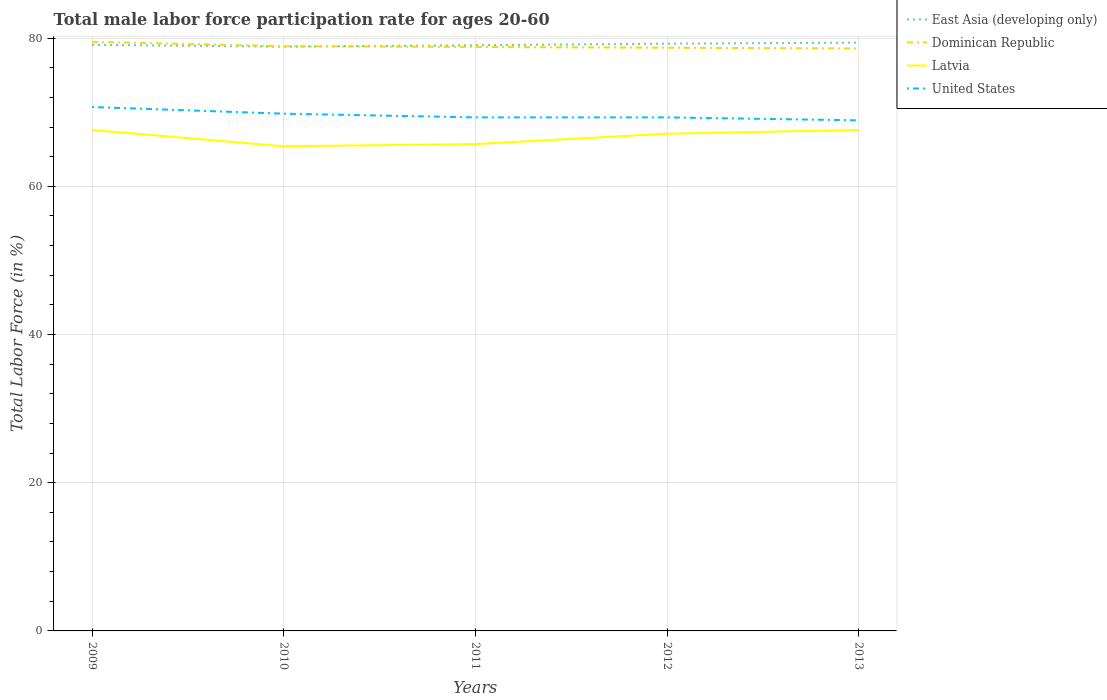How many different coloured lines are there?
Ensure brevity in your answer.  4. Is the number of lines equal to the number of legend labels?
Provide a short and direct response. Yes. Across all years, what is the maximum male labor force participation rate in United States?
Give a very brief answer. 68.9. In which year was the male labor force participation rate in East Asia (developing only) maximum?
Your response must be concise. 2010. What is the total male labor force participation rate in Dominican Republic in the graph?
Your answer should be compact. 0.6. What is the difference between the highest and the second highest male labor force participation rate in United States?
Your response must be concise. 1.8. What is the difference between the highest and the lowest male labor force participation rate in Dominican Republic?
Give a very brief answer. 2. How many years are there in the graph?
Your response must be concise. 5. What is the difference between two consecutive major ticks on the Y-axis?
Your response must be concise. 20. Are the values on the major ticks of Y-axis written in scientific E-notation?
Keep it short and to the point. No. Where does the legend appear in the graph?
Offer a terse response. Top right. How are the legend labels stacked?
Offer a very short reply. Vertical. What is the title of the graph?
Give a very brief answer. Total male labor force participation rate for ages 20-60. What is the label or title of the Y-axis?
Offer a terse response. Total Labor Force (in %). What is the Total Labor Force (in %) in East Asia (developing only) in 2009?
Your answer should be compact. 79.09. What is the Total Labor Force (in %) of Dominican Republic in 2009?
Give a very brief answer. 79.5. What is the Total Labor Force (in %) in Latvia in 2009?
Offer a terse response. 67.6. What is the Total Labor Force (in %) in United States in 2009?
Offer a terse response. 70.7. What is the Total Labor Force (in %) in East Asia (developing only) in 2010?
Give a very brief answer. 78.84. What is the Total Labor Force (in %) in Dominican Republic in 2010?
Your answer should be very brief. 78.9. What is the Total Labor Force (in %) in Latvia in 2010?
Your answer should be very brief. 65.4. What is the Total Labor Force (in %) in United States in 2010?
Keep it short and to the point. 69.8. What is the Total Labor Force (in %) of East Asia (developing only) in 2011?
Keep it short and to the point. 79.03. What is the Total Labor Force (in %) in Dominican Republic in 2011?
Your response must be concise. 78.8. What is the Total Labor Force (in %) in Latvia in 2011?
Give a very brief answer. 65.7. What is the Total Labor Force (in %) of United States in 2011?
Provide a succinct answer. 69.3. What is the Total Labor Force (in %) of East Asia (developing only) in 2012?
Make the answer very short. 79.25. What is the Total Labor Force (in %) in Dominican Republic in 2012?
Your answer should be compact. 78.7. What is the Total Labor Force (in %) of Latvia in 2012?
Provide a succinct answer. 67.1. What is the Total Labor Force (in %) of United States in 2012?
Give a very brief answer. 69.3. What is the Total Labor Force (in %) in East Asia (developing only) in 2013?
Your answer should be compact. 79.39. What is the Total Labor Force (in %) in Dominican Republic in 2013?
Offer a terse response. 78.6. What is the Total Labor Force (in %) of Latvia in 2013?
Give a very brief answer. 67.6. What is the Total Labor Force (in %) of United States in 2013?
Provide a short and direct response. 68.9. Across all years, what is the maximum Total Labor Force (in %) of East Asia (developing only)?
Offer a very short reply. 79.39. Across all years, what is the maximum Total Labor Force (in %) of Dominican Republic?
Ensure brevity in your answer.  79.5. Across all years, what is the maximum Total Labor Force (in %) of Latvia?
Ensure brevity in your answer.  67.6. Across all years, what is the maximum Total Labor Force (in %) of United States?
Ensure brevity in your answer.  70.7. Across all years, what is the minimum Total Labor Force (in %) of East Asia (developing only)?
Ensure brevity in your answer.  78.84. Across all years, what is the minimum Total Labor Force (in %) in Dominican Republic?
Your answer should be compact. 78.6. Across all years, what is the minimum Total Labor Force (in %) in Latvia?
Provide a succinct answer. 65.4. Across all years, what is the minimum Total Labor Force (in %) in United States?
Give a very brief answer. 68.9. What is the total Total Labor Force (in %) in East Asia (developing only) in the graph?
Ensure brevity in your answer.  395.6. What is the total Total Labor Force (in %) of Dominican Republic in the graph?
Provide a succinct answer. 394.5. What is the total Total Labor Force (in %) in Latvia in the graph?
Give a very brief answer. 333.4. What is the total Total Labor Force (in %) in United States in the graph?
Keep it short and to the point. 348. What is the difference between the Total Labor Force (in %) in East Asia (developing only) in 2009 and that in 2010?
Give a very brief answer. 0.25. What is the difference between the Total Labor Force (in %) in Latvia in 2009 and that in 2010?
Offer a terse response. 2.2. What is the difference between the Total Labor Force (in %) in United States in 2009 and that in 2010?
Give a very brief answer. 0.9. What is the difference between the Total Labor Force (in %) of East Asia (developing only) in 2009 and that in 2011?
Offer a very short reply. 0.06. What is the difference between the Total Labor Force (in %) in Latvia in 2009 and that in 2011?
Keep it short and to the point. 1.9. What is the difference between the Total Labor Force (in %) in United States in 2009 and that in 2011?
Make the answer very short. 1.4. What is the difference between the Total Labor Force (in %) in East Asia (developing only) in 2009 and that in 2012?
Ensure brevity in your answer.  -0.16. What is the difference between the Total Labor Force (in %) of Latvia in 2009 and that in 2012?
Provide a succinct answer. 0.5. What is the difference between the Total Labor Force (in %) in United States in 2009 and that in 2012?
Offer a very short reply. 1.4. What is the difference between the Total Labor Force (in %) of East Asia (developing only) in 2009 and that in 2013?
Ensure brevity in your answer.  -0.3. What is the difference between the Total Labor Force (in %) of Dominican Republic in 2009 and that in 2013?
Ensure brevity in your answer.  0.9. What is the difference between the Total Labor Force (in %) of Latvia in 2009 and that in 2013?
Offer a very short reply. 0. What is the difference between the Total Labor Force (in %) in East Asia (developing only) in 2010 and that in 2011?
Ensure brevity in your answer.  -0.19. What is the difference between the Total Labor Force (in %) in Dominican Republic in 2010 and that in 2011?
Keep it short and to the point. 0.1. What is the difference between the Total Labor Force (in %) of East Asia (developing only) in 2010 and that in 2012?
Your answer should be very brief. -0.4. What is the difference between the Total Labor Force (in %) of Dominican Republic in 2010 and that in 2012?
Your response must be concise. 0.2. What is the difference between the Total Labor Force (in %) in East Asia (developing only) in 2010 and that in 2013?
Provide a succinct answer. -0.55. What is the difference between the Total Labor Force (in %) of United States in 2010 and that in 2013?
Offer a very short reply. 0.9. What is the difference between the Total Labor Force (in %) in East Asia (developing only) in 2011 and that in 2012?
Ensure brevity in your answer.  -0.22. What is the difference between the Total Labor Force (in %) in Dominican Republic in 2011 and that in 2012?
Your answer should be compact. 0.1. What is the difference between the Total Labor Force (in %) of Latvia in 2011 and that in 2012?
Your answer should be very brief. -1.4. What is the difference between the Total Labor Force (in %) of East Asia (developing only) in 2011 and that in 2013?
Provide a succinct answer. -0.36. What is the difference between the Total Labor Force (in %) of Dominican Republic in 2011 and that in 2013?
Offer a terse response. 0.2. What is the difference between the Total Labor Force (in %) of Latvia in 2011 and that in 2013?
Provide a short and direct response. -1.9. What is the difference between the Total Labor Force (in %) of United States in 2011 and that in 2013?
Your answer should be compact. 0.4. What is the difference between the Total Labor Force (in %) of East Asia (developing only) in 2012 and that in 2013?
Offer a very short reply. -0.14. What is the difference between the Total Labor Force (in %) of Dominican Republic in 2012 and that in 2013?
Your answer should be very brief. 0.1. What is the difference between the Total Labor Force (in %) of Latvia in 2012 and that in 2013?
Offer a very short reply. -0.5. What is the difference between the Total Labor Force (in %) of United States in 2012 and that in 2013?
Offer a terse response. 0.4. What is the difference between the Total Labor Force (in %) in East Asia (developing only) in 2009 and the Total Labor Force (in %) in Dominican Republic in 2010?
Give a very brief answer. 0.19. What is the difference between the Total Labor Force (in %) of East Asia (developing only) in 2009 and the Total Labor Force (in %) of Latvia in 2010?
Offer a terse response. 13.69. What is the difference between the Total Labor Force (in %) in East Asia (developing only) in 2009 and the Total Labor Force (in %) in United States in 2010?
Your answer should be compact. 9.29. What is the difference between the Total Labor Force (in %) of Latvia in 2009 and the Total Labor Force (in %) of United States in 2010?
Your response must be concise. -2.2. What is the difference between the Total Labor Force (in %) in East Asia (developing only) in 2009 and the Total Labor Force (in %) in Dominican Republic in 2011?
Provide a short and direct response. 0.29. What is the difference between the Total Labor Force (in %) of East Asia (developing only) in 2009 and the Total Labor Force (in %) of Latvia in 2011?
Your response must be concise. 13.39. What is the difference between the Total Labor Force (in %) in East Asia (developing only) in 2009 and the Total Labor Force (in %) in United States in 2011?
Ensure brevity in your answer.  9.79. What is the difference between the Total Labor Force (in %) in Latvia in 2009 and the Total Labor Force (in %) in United States in 2011?
Keep it short and to the point. -1.7. What is the difference between the Total Labor Force (in %) in East Asia (developing only) in 2009 and the Total Labor Force (in %) in Dominican Republic in 2012?
Provide a succinct answer. 0.39. What is the difference between the Total Labor Force (in %) of East Asia (developing only) in 2009 and the Total Labor Force (in %) of Latvia in 2012?
Your answer should be compact. 11.99. What is the difference between the Total Labor Force (in %) in East Asia (developing only) in 2009 and the Total Labor Force (in %) in United States in 2012?
Give a very brief answer. 9.79. What is the difference between the Total Labor Force (in %) of Dominican Republic in 2009 and the Total Labor Force (in %) of United States in 2012?
Offer a very short reply. 10.2. What is the difference between the Total Labor Force (in %) of Latvia in 2009 and the Total Labor Force (in %) of United States in 2012?
Provide a succinct answer. -1.7. What is the difference between the Total Labor Force (in %) in East Asia (developing only) in 2009 and the Total Labor Force (in %) in Dominican Republic in 2013?
Make the answer very short. 0.49. What is the difference between the Total Labor Force (in %) in East Asia (developing only) in 2009 and the Total Labor Force (in %) in Latvia in 2013?
Offer a terse response. 11.49. What is the difference between the Total Labor Force (in %) in East Asia (developing only) in 2009 and the Total Labor Force (in %) in United States in 2013?
Your response must be concise. 10.19. What is the difference between the Total Labor Force (in %) in Dominican Republic in 2009 and the Total Labor Force (in %) in Latvia in 2013?
Give a very brief answer. 11.9. What is the difference between the Total Labor Force (in %) of Latvia in 2009 and the Total Labor Force (in %) of United States in 2013?
Your answer should be very brief. -1.3. What is the difference between the Total Labor Force (in %) in East Asia (developing only) in 2010 and the Total Labor Force (in %) in Dominican Republic in 2011?
Offer a very short reply. 0.04. What is the difference between the Total Labor Force (in %) of East Asia (developing only) in 2010 and the Total Labor Force (in %) of Latvia in 2011?
Keep it short and to the point. 13.14. What is the difference between the Total Labor Force (in %) of East Asia (developing only) in 2010 and the Total Labor Force (in %) of United States in 2011?
Offer a very short reply. 9.54. What is the difference between the Total Labor Force (in %) of Dominican Republic in 2010 and the Total Labor Force (in %) of Latvia in 2011?
Offer a terse response. 13.2. What is the difference between the Total Labor Force (in %) of Latvia in 2010 and the Total Labor Force (in %) of United States in 2011?
Your answer should be very brief. -3.9. What is the difference between the Total Labor Force (in %) in East Asia (developing only) in 2010 and the Total Labor Force (in %) in Dominican Republic in 2012?
Give a very brief answer. 0.14. What is the difference between the Total Labor Force (in %) in East Asia (developing only) in 2010 and the Total Labor Force (in %) in Latvia in 2012?
Your answer should be compact. 11.74. What is the difference between the Total Labor Force (in %) in East Asia (developing only) in 2010 and the Total Labor Force (in %) in United States in 2012?
Offer a very short reply. 9.54. What is the difference between the Total Labor Force (in %) in Dominican Republic in 2010 and the Total Labor Force (in %) in Latvia in 2012?
Offer a terse response. 11.8. What is the difference between the Total Labor Force (in %) of East Asia (developing only) in 2010 and the Total Labor Force (in %) of Dominican Republic in 2013?
Provide a succinct answer. 0.24. What is the difference between the Total Labor Force (in %) of East Asia (developing only) in 2010 and the Total Labor Force (in %) of Latvia in 2013?
Offer a terse response. 11.24. What is the difference between the Total Labor Force (in %) of East Asia (developing only) in 2010 and the Total Labor Force (in %) of United States in 2013?
Your response must be concise. 9.94. What is the difference between the Total Labor Force (in %) in East Asia (developing only) in 2011 and the Total Labor Force (in %) in Dominican Republic in 2012?
Ensure brevity in your answer.  0.33. What is the difference between the Total Labor Force (in %) in East Asia (developing only) in 2011 and the Total Labor Force (in %) in Latvia in 2012?
Your answer should be compact. 11.93. What is the difference between the Total Labor Force (in %) of East Asia (developing only) in 2011 and the Total Labor Force (in %) of United States in 2012?
Keep it short and to the point. 9.73. What is the difference between the Total Labor Force (in %) in Dominican Republic in 2011 and the Total Labor Force (in %) in Latvia in 2012?
Ensure brevity in your answer.  11.7. What is the difference between the Total Labor Force (in %) in Latvia in 2011 and the Total Labor Force (in %) in United States in 2012?
Provide a short and direct response. -3.6. What is the difference between the Total Labor Force (in %) of East Asia (developing only) in 2011 and the Total Labor Force (in %) of Dominican Republic in 2013?
Offer a very short reply. 0.43. What is the difference between the Total Labor Force (in %) of East Asia (developing only) in 2011 and the Total Labor Force (in %) of Latvia in 2013?
Keep it short and to the point. 11.43. What is the difference between the Total Labor Force (in %) of East Asia (developing only) in 2011 and the Total Labor Force (in %) of United States in 2013?
Keep it short and to the point. 10.13. What is the difference between the Total Labor Force (in %) of East Asia (developing only) in 2012 and the Total Labor Force (in %) of Dominican Republic in 2013?
Ensure brevity in your answer.  0.65. What is the difference between the Total Labor Force (in %) of East Asia (developing only) in 2012 and the Total Labor Force (in %) of Latvia in 2013?
Offer a very short reply. 11.65. What is the difference between the Total Labor Force (in %) in East Asia (developing only) in 2012 and the Total Labor Force (in %) in United States in 2013?
Provide a succinct answer. 10.35. What is the difference between the Total Labor Force (in %) of Dominican Republic in 2012 and the Total Labor Force (in %) of United States in 2013?
Ensure brevity in your answer.  9.8. What is the difference between the Total Labor Force (in %) in Latvia in 2012 and the Total Labor Force (in %) in United States in 2013?
Your answer should be compact. -1.8. What is the average Total Labor Force (in %) of East Asia (developing only) per year?
Provide a succinct answer. 79.12. What is the average Total Labor Force (in %) of Dominican Republic per year?
Give a very brief answer. 78.9. What is the average Total Labor Force (in %) of Latvia per year?
Your answer should be very brief. 66.68. What is the average Total Labor Force (in %) of United States per year?
Your answer should be compact. 69.6. In the year 2009, what is the difference between the Total Labor Force (in %) of East Asia (developing only) and Total Labor Force (in %) of Dominican Republic?
Ensure brevity in your answer.  -0.41. In the year 2009, what is the difference between the Total Labor Force (in %) of East Asia (developing only) and Total Labor Force (in %) of Latvia?
Offer a terse response. 11.49. In the year 2009, what is the difference between the Total Labor Force (in %) of East Asia (developing only) and Total Labor Force (in %) of United States?
Your answer should be very brief. 8.39. In the year 2010, what is the difference between the Total Labor Force (in %) of East Asia (developing only) and Total Labor Force (in %) of Dominican Republic?
Your answer should be very brief. -0.06. In the year 2010, what is the difference between the Total Labor Force (in %) in East Asia (developing only) and Total Labor Force (in %) in Latvia?
Keep it short and to the point. 13.44. In the year 2010, what is the difference between the Total Labor Force (in %) of East Asia (developing only) and Total Labor Force (in %) of United States?
Give a very brief answer. 9.04. In the year 2010, what is the difference between the Total Labor Force (in %) in Dominican Republic and Total Labor Force (in %) in United States?
Your answer should be very brief. 9.1. In the year 2011, what is the difference between the Total Labor Force (in %) of East Asia (developing only) and Total Labor Force (in %) of Dominican Republic?
Ensure brevity in your answer.  0.23. In the year 2011, what is the difference between the Total Labor Force (in %) in East Asia (developing only) and Total Labor Force (in %) in Latvia?
Keep it short and to the point. 13.33. In the year 2011, what is the difference between the Total Labor Force (in %) in East Asia (developing only) and Total Labor Force (in %) in United States?
Ensure brevity in your answer.  9.73. In the year 2012, what is the difference between the Total Labor Force (in %) of East Asia (developing only) and Total Labor Force (in %) of Dominican Republic?
Keep it short and to the point. 0.55. In the year 2012, what is the difference between the Total Labor Force (in %) of East Asia (developing only) and Total Labor Force (in %) of Latvia?
Your response must be concise. 12.15. In the year 2012, what is the difference between the Total Labor Force (in %) in East Asia (developing only) and Total Labor Force (in %) in United States?
Give a very brief answer. 9.95. In the year 2012, what is the difference between the Total Labor Force (in %) of Dominican Republic and Total Labor Force (in %) of Latvia?
Make the answer very short. 11.6. In the year 2013, what is the difference between the Total Labor Force (in %) of East Asia (developing only) and Total Labor Force (in %) of Dominican Republic?
Your answer should be compact. 0.79. In the year 2013, what is the difference between the Total Labor Force (in %) in East Asia (developing only) and Total Labor Force (in %) in Latvia?
Ensure brevity in your answer.  11.79. In the year 2013, what is the difference between the Total Labor Force (in %) in East Asia (developing only) and Total Labor Force (in %) in United States?
Give a very brief answer. 10.49. In the year 2013, what is the difference between the Total Labor Force (in %) in Latvia and Total Labor Force (in %) in United States?
Provide a succinct answer. -1.3. What is the ratio of the Total Labor Force (in %) in Dominican Republic in 2009 to that in 2010?
Provide a short and direct response. 1.01. What is the ratio of the Total Labor Force (in %) in Latvia in 2009 to that in 2010?
Your answer should be compact. 1.03. What is the ratio of the Total Labor Force (in %) of United States in 2009 to that in 2010?
Ensure brevity in your answer.  1.01. What is the ratio of the Total Labor Force (in %) in East Asia (developing only) in 2009 to that in 2011?
Provide a succinct answer. 1. What is the ratio of the Total Labor Force (in %) in Dominican Republic in 2009 to that in 2011?
Offer a very short reply. 1.01. What is the ratio of the Total Labor Force (in %) of Latvia in 2009 to that in 2011?
Make the answer very short. 1.03. What is the ratio of the Total Labor Force (in %) of United States in 2009 to that in 2011?
Offer a very short reply. 1.02. What is the ratio of the Total Labor Force (in %) in East Asia (developing only) in 2009 to that in 2012?
Offer a very short reply. 1. What is the ratio of the Total Labor Force (in %) in Dominican Republic in 2009 to that in 2012?
Your answer should be compact. 1.01. What is the ratio of the Total Labor Force (in %) in Latvia in 2009 to that in 2012?
Keep it short and to the point. 1.01. What is the ratio of the Total Labor Force (in %) of United States in 2009 to that in 2012?
Keep it short and to the point. 1.02. What is the ratio of the Total Labor Force (in %) of Dominican Republic in 2009 to that in 2013?
Provide a short and direct response. 1.01. What is the ratio of the Total Labor Force (in %) of United States in 2009 to that in 2013?
Ensure brevity in your answer.  1.03. What is the ratio of the Total Labor Force (in %) of Latvia in 2010 to that in 2011?
Your answer should be very brief. 1. What is the ratio of the Total Labor Force (in %) of Latvia in 2010 to that in 2012?
Give a very brief answer. 0.97. What is the ratio of the Total Labor Force (in %) of United States in 2010 to that in 2012?
Offer a terse response. 1.01. What is the ratio of the Total Labor Force (in %) in East Asia (developing only) in 2010 to that in 2013?
Make the answer very short. 0.99. What is the ratio of the Total Labor Force (in %) in Latvia in 2010 to that in 2013?
Your answer should be very brief. 0.97. What is the ratio of the Total Labor Force (in %) in United States in 2010 to that in 2013?
Provide a succinct answer. 1.01. What is the ratio of the Total Labor Force (in %) of East Asia (developing only) in 2011 to that in 2012?
Provide a succinct answer. 1. What is the ratio of the Total Labor Force (in %) in Latvia in 2011 to that in 2012?
Keep it short and to the point. 0.98. What is the ratio of the Total Labor Force (in %) in Latvia in 2011 to that in 2013?
Keep it short and to the point. 0.97. What is the ratio of the Total Labor Force (in %) in United States in 2011 to that in 2013?
Your answer should be compact. 1.01. What is the ratio of the Total Labor Force (in %) of Dominican Republic in 2012 to that in 2013?
Your answer should be very brief. 1. What is the difference between the highest and the second highest Total Labor Force (in %) in East Asia (developing only)?
Your response must be concise. 0.14. What is the difference between the highest and the second highest Total Labor Force (in %) in Dominican Republic?
Provide a short and direct response. 0.6. What is the difference between the highest and the second highest Total Labor Force (in %) of Latvia?
Provide a short and direct response. 0. What is the difference between the highest and the second highest Total Labor Force (in %) in United States?
Your answer should be very brief. 0.9. What is the difference between the highest and the lowest Total Labor Force (in %) in East Asia (developing only)?
Provide a succinct answer. 0.55. What is the difference between the highest and the lowest Total Labor Force (in %) of Dominican Republic?
Make the answer very short. 0.9. 